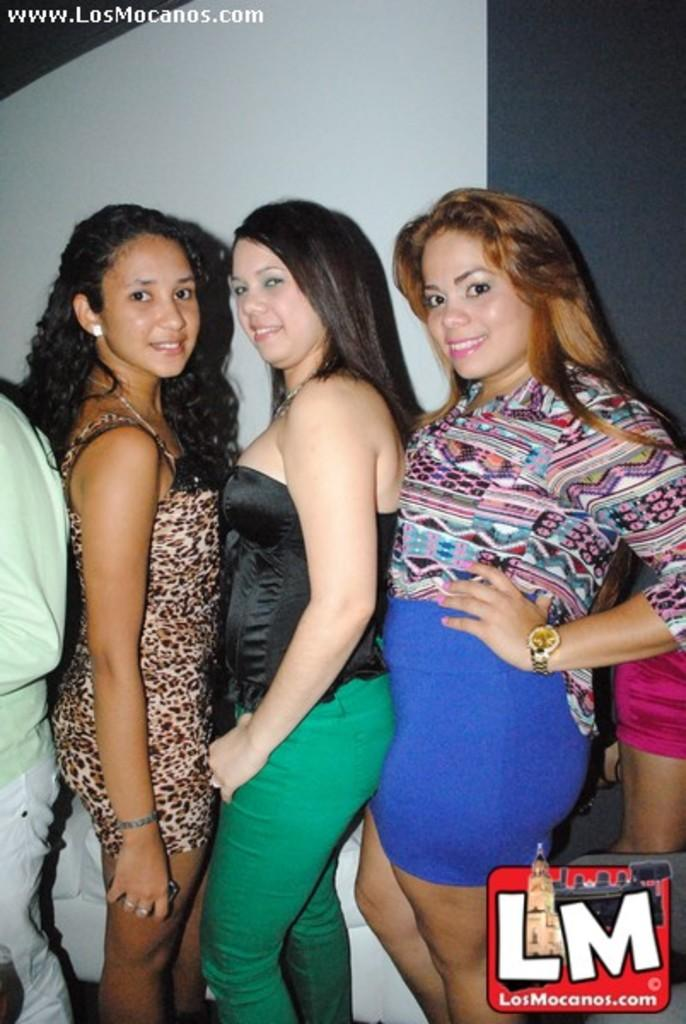How many women are in the image? There are three women in the image. What is the facial expression of the women? The women are smiling. Are there any other people in the image besides the women? Yes, there are people standing on either side of the women. What can be seen in the background of the image? There is a wall visible in the image. What type of zinc is being used to construct the wall in the image? There is no mention of zinc or any construction materials in the image; it only shows the women and the wall. 